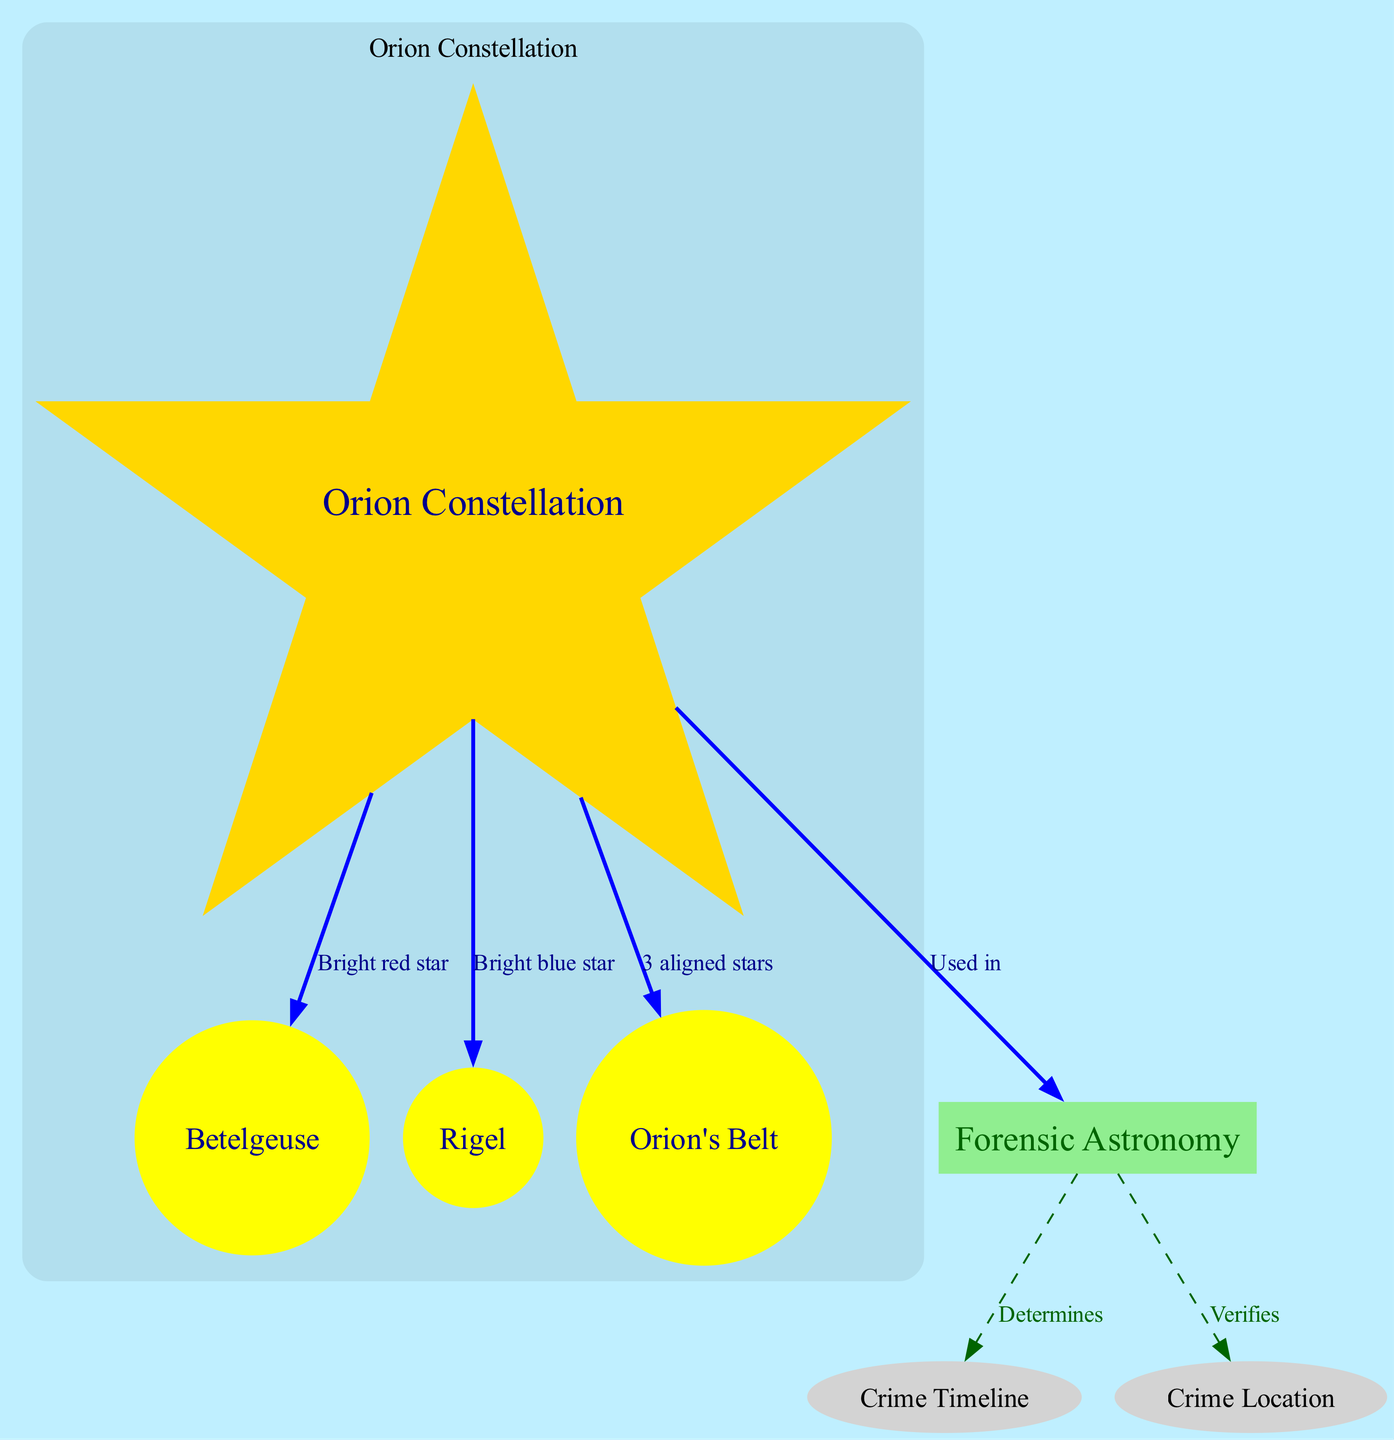What is the primary star of the Orion constellation? The diagram identifies Betelgeuse as one of the primary stars of the Orion constellation through the connection labeled "Bright red star."
Answer: Betelgeuse How many main stars are shown in the Orion constellation? The diagram depicts three significant stars: Betelgeuse, Rigel, and Orion's Belt. This can be counted directly from the nodes linked to "Orion Constellation."
Answer: Three What color is Rigel represented as in the diagram? Rigel is labeled as a "Bright blue star" which indicates its color visually within the diagram.
Answer: Blue What does forensic astronomy determine in the context of criminal cases? The connection between "Forensic Astronomy" and "Crime Timeline" indicates that it determines the timeline of events related to a crime as indicated in the diagram.
Answer: Timeline How does forensic astronomy verify information related to a crime? The connection from "Forensic Astronomy" to "Crime Location" shows that forensic astronomy is used to verify the physical location of the crime. This relationship provides insight into its applications in criminal defense.
Answer: Location Which stars are represented as part of Orion's Belt? The diagram denotes Orion's Belt as having three aligned stars, which points to its configuration in the celestial diagram representing the Orion constellation.
Answer: Three aligned stars What is the significance of the edges labeled in the diagram? The edges convey relationships between the nodes, illustrating how elements like the Orion constellation are contextually connected to forensic astronomy and its applications in criminal cases.
Answer: Relationships What does the bright red star Betelgeuse signify in the diagram? The label indicates its distinct feature as a prominent star within the Orion constellation, carrying significance for celestial navigation and forensic applications.
Answer: Bright red star What connection does the Orion constellation have with forensic astronomy? The diagram states that the Orion constellation is utilized in forensic astronomy, which complicates its role in criminal investigations, establishing its relevance to the case context.
Answer: Used in 